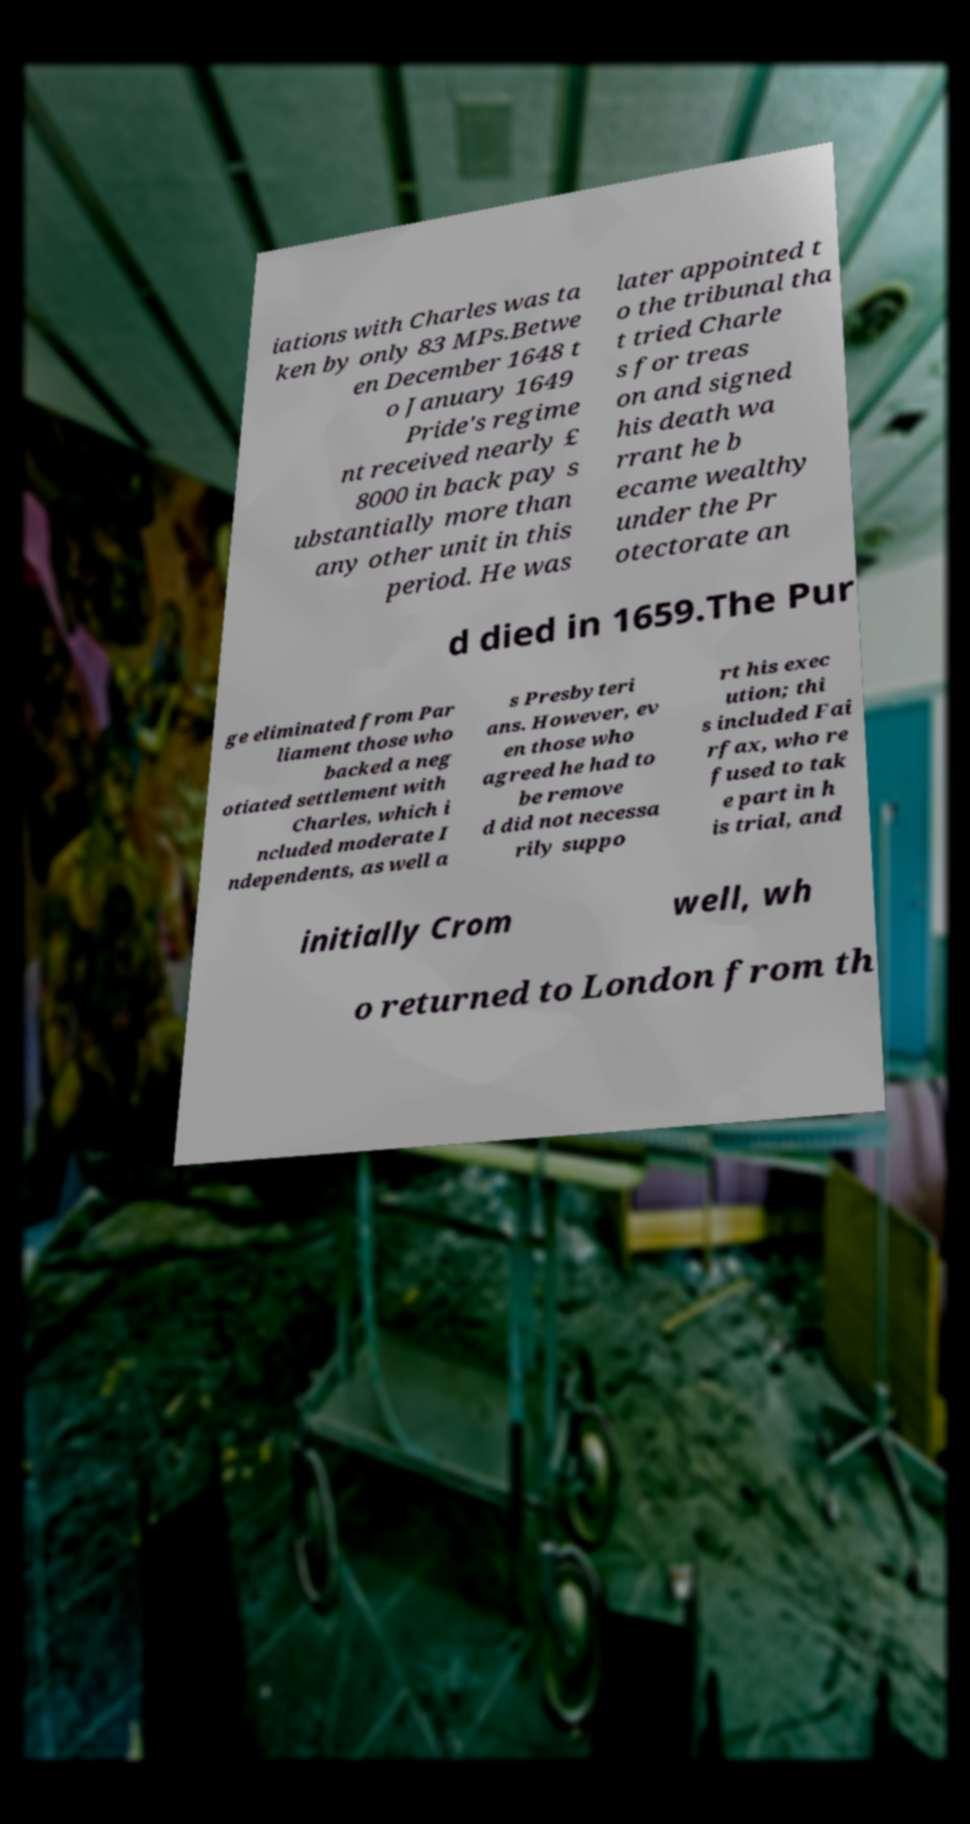What messages or text are displayed in this image? I need them in a readable, typed format. iations with Charles was ta ken by only 83 MPs.Betwe en December 1648 t o January 1649 Pride's regime nt received nearly £ 8000 in back pay s ubstantially more than any other unit in this period. He was later appointed t o the tribunal tha t tried Charle s for treas on and signed his death wa rrant he b ecame wealthy under the Pr otectorate an d died in 1659.The Pur ge eliminated from Par liament those who backed a neg otiated settlement with Charles, which i ncluded moderate I ndependents, as well a s Presbyteri ans. However, ev en those who agreed he had to be remove d did not necessa rily suppo rt his exec ution; thi s included Fai rfax, who re fused to tak e part in h is trial, and initially Crom well, wh o returned to London from th 